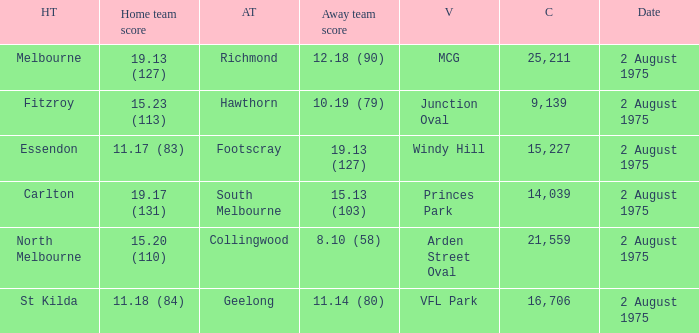How many people attended the game at VFL Park? 16706.0. 